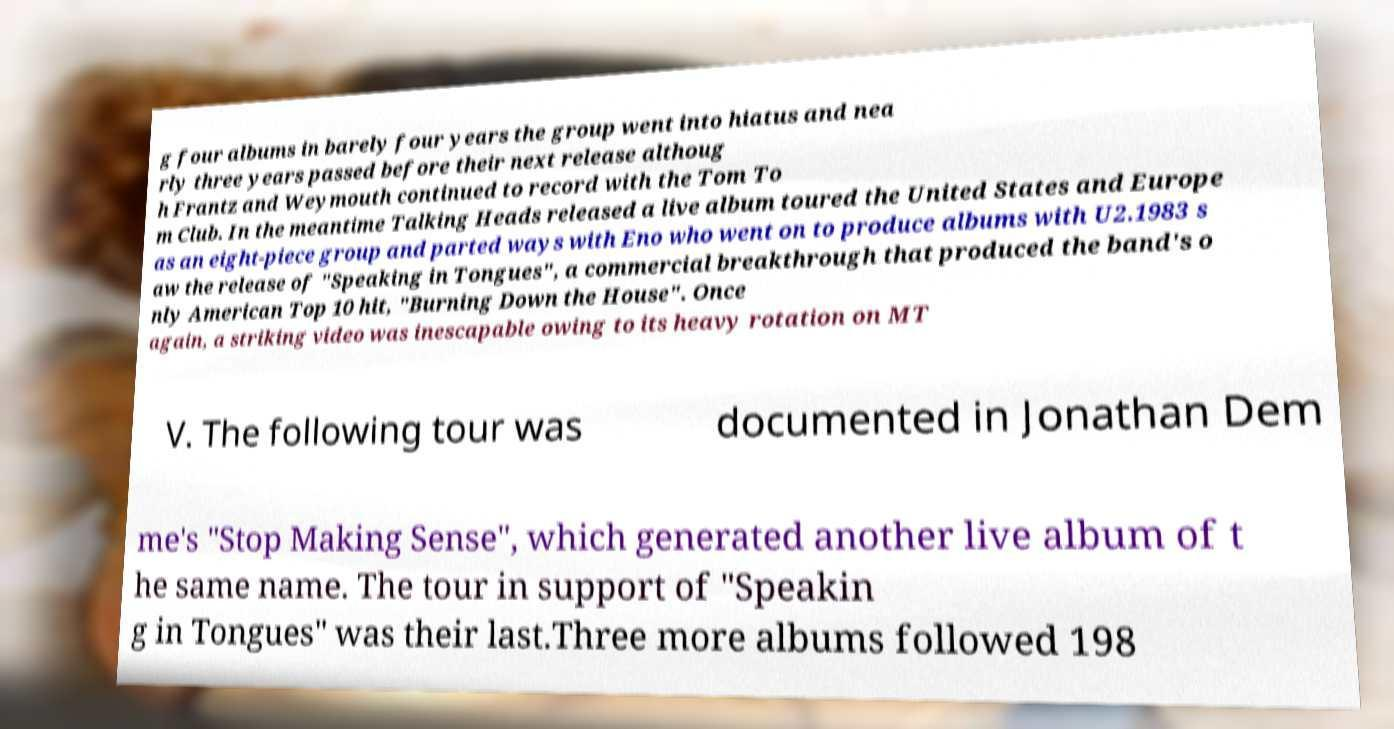Please read and relay the text visible in this image. What does it say? g four albums in barely four years the group went into hiatus and nea rly three years passed before their next release althoug h Frantz and Weymouth continued to record with the Tom To m Club. In the meantime Talking Heads released a live album toured the United States and Europe as an eight-piece group and parted ways with Eno who went on to produce albums with U2.1983 s aw the release of "Speaking in Tongues", a commercial breakthrough that produced the band's o nly American Top 10 hit, "Burning Down the House". Once again, a striking video was inescapable owing to its heavy rotation on MT V. The following tour was documented in Jonathan Dem me's "Stop Making Sense", which generated another live album of t he same name. The tour in support of "Speakin g in Tongues" was their last.Three more albums followed 198 